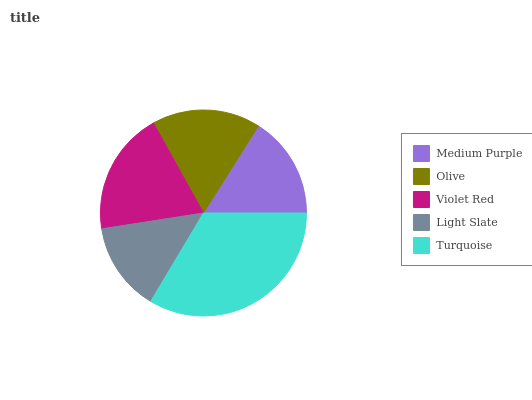Is Light Slate the minimum?
Answer yes or no. Yes. Is Turquoise the maximum?
Answer yes or no. Yes. Is Olive the minimum?
Answer yes or no. No. Is Olive the maximum?
Answer yes or no. No. Is Olive greater than Medium Purple?
Answer yes or no. Yes. Is Medium Purple less than Olive?
Answer yes or no. Yes. Is Medium Purple greater than Olive?
Answer yes or no. No. Is Olive less than Medium Purple?
Answer yes or no. No. Is Olive the high median?
Answer yes or no. Yes. Is Olive the low median?
Answer yes or no. Yes. Is Turquoise the high median?
Answer yes or no. No. Is Medium Purple the low median?
Answer yes or no. No. 